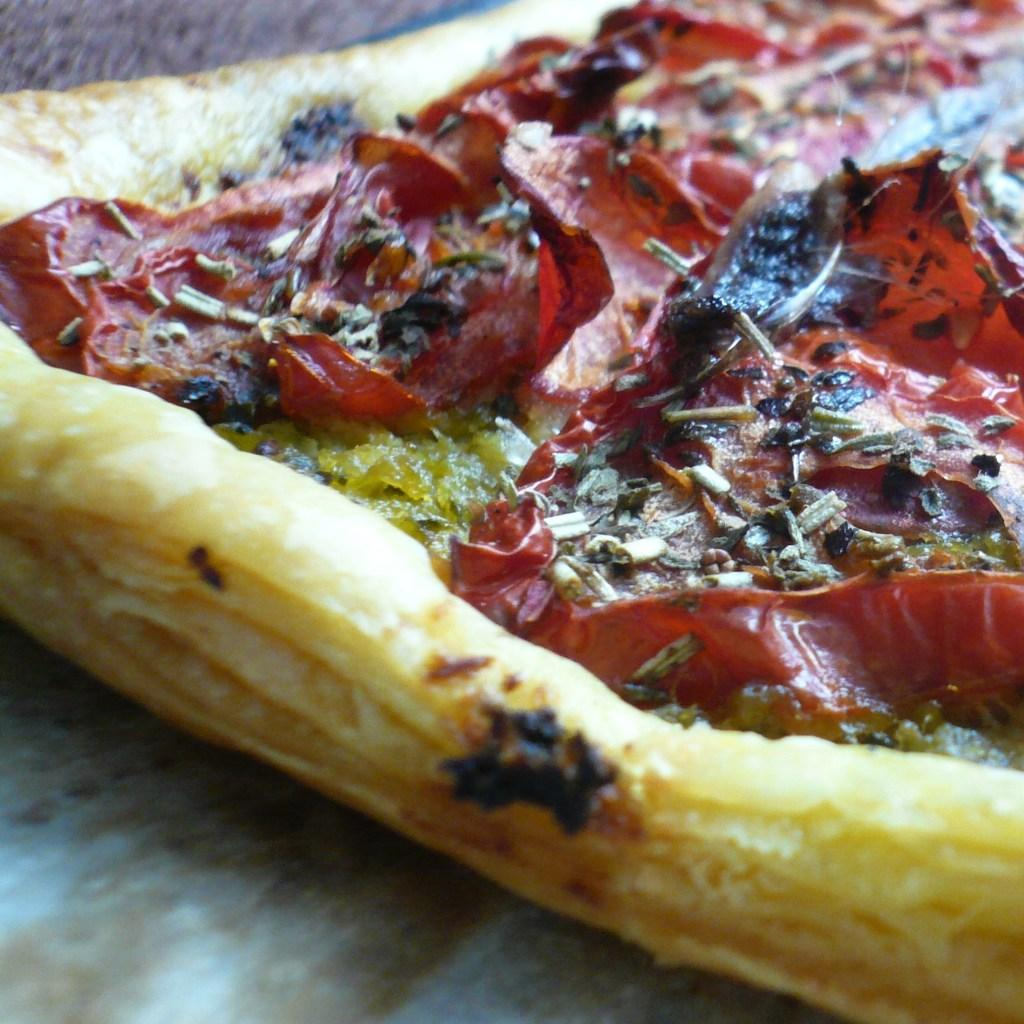What type of food item is visible in the image? There is a food item in the image, but the specific type cannot be determined from the provided facts. Can you describe the colors of the food item? The food item has brown, red, and green colors. What is the purpose of the bike in the image? There is no bike present in the image, so it is not possible to determine its purpose. 